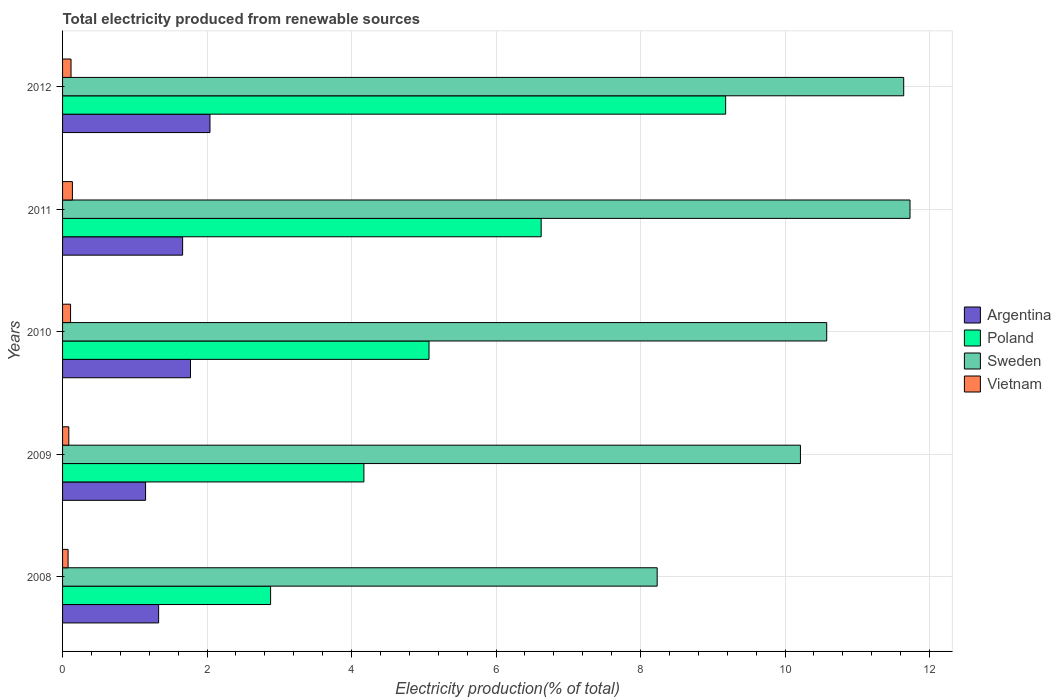Are the number of bars per tick equal to the number of legend labels?
Your answer should be very brief. Yes. How many bars are there on the 4th tick from the top?
Your answer should be very brief. 4. How many bars are there on the 3rd tick from the bottom?
Your answer should be very brief. 4. In how many cases, is the number of bars for a given year not equal to the number of legend labels?
Provide a short and direct response. 0. What is the total electricity produced in Sweden in 2012?
Offer a very short reply. 11.64. Across all years, what is the maximum total electricity produced in Poland?
Your response must be concise. 9.18. Across all years, what is the minimum total electricity produced in Argentina?
Keep it short and to the point. 1.15. In which year was the total electricity produced in Vietnam maximum?
Make the answer very short. 2011. What is the total total electricity produced in Argentina in the graph?
Offer a terse response. 7.95. What is the difference between the total electricity produced in Poland in 2009 and that in 2012?
Your answer should be very brief. -5.01. What is the difference between the total electricity produced in Sweden in 2008 and the total electricity produced in Vietnam in 2012?
Give a very brief answer. 8.11. What is the average total electricity produced in Poland per year?
Your response must be concise. 5.59. In the year 2012, what is the difference between the total electricity produced in Poland and total electricity produced in Vietnam?
Offer a terse response. 9.06. What is the ratio of the total electricity produced in Poland in 2009 to that in 2010?
Make the answer very short. 0.82. What is the difference between the highest and the second highest total electricity produced in Poland?
Offer a terse response. 2.55. What is the difference between the highest and the lowest total electricity produced in Vietnam?
Keep it short and to the point. 0.06. Is it the case that in every year, the sum of the total electricity produced in Vietnam and total electricity produced in Sweden is greater than the sum of total electricity produced in Argentina and total electricity produced in Poland?
Provide a short and direct response. Yes. Is it the case that in every year, the sum of the total electricity produced in Poland and total electricity produced in Sweden is greater than the total electricity produced in Argentina?
Make the answer very short. Yes. How many bars are there?
Provide a short and direct response. 20. How many years are there in the graph?
Your answer should be very brief. 5. Are the values on the major ticks of X-axis written in scientific E-notation?
Your response must be concise. No. Does the graph contain any zero values?
Your answer should be very brief. No. Does the graph contain grids?
Offer a terse response. Yes. How are the legend labels stacked?
Give a very brief answer. Vertical. What is the title of the graph?
Provide a short and direct response. Total electricity produced from renewable sources. Does "Japan" appear as one of the legend labels in the graph?
Offer a terse response. No. What is the label or title of the X-axis?
Your answer should be very brief. Electricity production(% of total). What is the label or title of the Y-axis?
Provide a succinct answer. Years. What is the Electricity production(% of total) in Argentina in 2008?
Give a very brief answer. 1.33. What is the Electricity production(% of total) in Poland in 2008?
Give a very brief answer. 2.88. What is the Electricity production(% of total) in Sweden in 2008?
Your answer should be very brief. 8.23. What is the Electricity production(% of total) in Vietnam in 2008?
Keep it short and to the point. 0.08. What is the Electricity production(% of total) in Argentina in 2009?
Make the answer very short. 1.15. What is the Electricity production(% of total) of Poland in 2009?
Provide a succinct answer. 4.17. What is the Electricity production(% of total) in Sweden in 2009?
Your answer should be compact. 10.21. What is the Electricity production(% of total) of Vietnam in 2009?
Make the answer very short. 0.09. What is the Electricity production(% of total) of Argentina in 2010?
Provide a short and direct response. 1.77. What is the Electricity production(% of total) of Poland in 2010?
Provide a short and direct response. 5.07. What is the Electricity production(% of total) in Sweden in 2010?
Your answer should be compact. 10.58. What is the Electricity production(% of total) of Vietnam in 2010?
Offer a terse response. 0.11. What is the Electricity production(% of total) of Argentina in 2011?
Offer a terse response. 1.66. What is the Electricity production(% of total) in Poland in 2011?
Offer a terse response. 6.62. What is the Electricity production(% of total) of Sweden in 2011?
Your answer should be compact. 11.73. What is the Electricity production(% of total) in Vietnam in 2011?
Make the answer very short. 0.14. What is the Electricity production(% of total) in Argentina in 2012?
Make the answer very short. 2.04. What is the Electricity production(% of total) of Poland in 2012?
Your answer should be compact. 9.18. What is the Electricity production(% of total) in Sweden in 2012?
Ensure brevity in your answer.  11.64. What is the Electricity production(% of total) of Vietnam in 2012?
Your answer should be very brief. 0.12. Across all years, what is the maximum Electricity production(% of total) of Argentina?
Ensure brevity in your answer.  2.04. Across all years, what is the maximum Electricity production(% of total) in Poland?
Keep it short and to the point. 9.18. Across all years, what is the maximum Electricity production(% of total) of Sweden?
Provide a succinct answer. 11.73. Across all years, what is the maximum Electricity production(% of total) in Vietnam?
Your answer should be very brief. 0.14. Across all years, what is the minimum Electricity production(% of total) in Argentina?
Make the answer very short. 1.15. Across all years, what is the minimum Electricity production(% of total) in Poland?
Give a very brief answer. 2.88. Across all years, what is the minimum Electricity production(% of total) in Sweden?
Provide a short and direct response. 8.23. Across all years, what is the minimum Electricity production(% of total) in Vietnam?
Provide a succinct answer. 0.08. What is the total Electricity production(% of total) in Argentina in the graph?
Provide a succinct answer. 7.95. What is the total Electricity production(% of total) of Poland in the graph?
Offer a terse response. 27.93. What is the total Electricity production(% of total) in Sweden in the graph?
Offer a very short reply. 52.39. What is the total Electricity production(% of total) of Vietnam in the graph?
Your response must be concise. 0.53. What is the difference between the Electricity production(% of total) in Argentina in 2008 and that in 2009?
Offer a very short reply. 0.18. What is the difference between the Electricity production(% of total) of Poland in 2008 and that in 2009?
Provide a short and direct response. -1.29. What is the difference between the Electricity production(% of total) in Sweden in 2008 and that in 2009?
Your answer should be very brief. -1.98. What is the difference between the Electricity production(% of total) of Vietnam in 2008 and that in 2009?
Offer a very short reply. -0.01. What is the difference between the Electricity production(% of total) of Argentina in 2008 and that in 2010?
Keep it short and to the point. -0.44. What is the difference between the Electricity production(% of total) in Poland in 2008 and that in 2010?
Ensure brevity in your answer.  -2.19. What is the difference between the Electricity production(% of total) in Sweden in 2008 and that in 2010?
Keep it short and to the point. -2.35. What is the difference between the Electricity production(% of total) in Vietnam in 2008 and that in 2010?
Provide a short and direct response. -0.03. What is the difference between the Electricity production(% of total) of Argentina in 2008 and that in 2011?
Your answer should be very brief. -0.33. What is the difference between the Electricity production(% of total) of Poland in 2008 and that in 2011?
Your answer should be very brief. -3.75. What is the difference between the Electricity production(% of total) in Sweden in 2008 and that in 2011?
Offer a very short reply. -3.5. What is the difference between the Electricity production(% of total) in Vietnam in 2008 and that in 2011?
Provide a short and direct response. -0.06. What is the difference between the Electricity production(% of total) of Argentina in 2008 and that in 2012?
Keep it short and to the point. -0.71. What is the difference between the Electricity production(% of total) of Poland in 2008 and that in 2012?
Your response must be concise. -6.3. What is the difference between the Electricity production(% of total) in Sweden in 2008 and that in 2012?
Offer a terse response. -3.41. What is the difference between the Electricity production(% of total) in Vietnam in 2008 and that in 2012?
Provide a succinct answer. -0.04. What is the difference between the Electricity production(% of total) of Argentina in 2009 and that in 2010?
Make the answer very short. -0.62. What is the difference between the Electricity production(% of total) of Poland in 2009 and that in 2010?
Provide a succinct answer. -0.9. What is the difference between the Electricity production(% of total) of Sweden in 2009 and that in 2010?
Offer a very short reply. -0.36. What is the difference between the Electricity production(% of total) in Vietnam in 2009 and that in 2010?
Provide a succinct answer. -0.02. What is the difference between the Electricity production(% of total) of Argentina in 2009 and that in 2011?
Make the answer very short. -0.51. What is the difference between the Electricity production(% of total) in Poland in 2009 and that in 2011?
Provide a short and direct response. -2.45. What is the difference between the Electricity production(% of total) in Sweden in 2009 and that in 2011?
Give a very brief answer. -1.52. What is the difference between the Electricity production(% of total) in Vietnam in 2009 and that in 2011?
Ensure brevity in your answer.  -0.05. What is the difference between the Electricity production(% of total) in Argentina in 2009 and that in 2012?
Ensure brevity in your answer.  -0.89. What is the difference between the Electricity production(% of total) of Poland in 2009 and that in 2012?
Give a very brief answer. -5.01. What is the difference between the Electricity production(% of total) in Sweden in 2009 and that in 2012?
Offer a terse response. -1.43. What is the difference between the Electricity production(% of total) in Vietnam in 2009 and that in 2012?
Offer a very short reply. -0.03. What is the difference between the Electricity production(% of total) in Argentina in 2010 and that in 2011?
Provide a succinct answer. 0.11. What is the difference between the Electricity production(% of total) in Poland in 2010 and that in 2011?
Your answer should be compact. -1.55. What is the difference between the Electricity production(% of total) in Sweden in 2010 and that in 2011?
Your answer should be very brief. -1.15. What is the difference between the Electricity production(% of total) in Vietnam in 2010 and that in 2011?
Keep it short and to the point. -0.03. What is the difference between the Electricity production(% of total) in Argentina in 2010 and that in 2012?
Your answer should be compact. -0.27. What is the difference between the Electricity production(% of total) in Poland in 2010 and that in 2012?
Give a very brief answer. -4.11. What is the difference between the Electricity production(% of total) in Sweden in 2010 and that in 2012?
Keep it short and to the point. -1.07. What is the difference between the Electricity production(% of total) of Vietnam in 2010 and that in 2012?
Your answer should be very brief. -0.01. What is the difference between the Electricity production(% of total) in Argentina in 2011 and that in 2012?
Make the answer very short. -0.38. What is the difference between the Electricity production(% of total) in Poland in 2011 and that in 2012?
Offer a terse response. -2.55. What is the difference between the Electricity production(% of total) of Sweden in 2011 and that in 2012?
Give a very brief answer. 0.09. What is the difference between the Electricity production(% of total) in Vietnam in 2011 and that in 2012?
Keep it short and to the point. 0.02. What is the difference between the Electricity production(% of total) in Argentina in 2008 and the Electricity production(% of total) in Poland in 2009?
Offer a terse response. -2.84. What is the difference between the Electricity production(% of total) of Argentina in 2008 and the Electricity production(% of total) of Sweden in 2009?
Offer a terse response. -8.88. What is the difference between the Electricity production(% of total) in Argentina in 2008 and the Electricity production(% of total) in Vietnam in 2009?
Your response must be concise. 1.24. What is the difference between the Electricity production(% of total) in Poland in 2008 and the Electricity production(% of total) in Sweden in 2009?
Your answer should be compact. -7.33. What is the difference between the Electricity production(% of total) of Poland in 2008 and the Electricity production(% of total) of Vietnam in 2009?
Provide a succinct answer. 2.79. What is the difference between the Electricity production(% of total) of Sweden in 2008 and the Electricity production(% of total) of Vietnam in 2009?
Make the answer very short. 8.14. What is the difference between the Electricity production(% of total) of Argentina in 2008 and the Electricity production(% of total) of Poland in 2010?
Offer a terse response. -3.74. What is the difference between the Electricity production(% of total) in Argentina in 2008 and the Electricity production(% of total) in Sweden in 2010?
Your response must be concise. -9.25. What is the difference between the Electricity production(% of total) of Argentina in 2008 and the Electricity production(% of total) of Vietnam in 2010?
Keep it short and to the point. 1.22. What is the difference between the Electricity production(% of total) in Poland in 2008 and the Electricity production(% of total) in Sweden in 2010?
Provide a short and direct response. -7.7. What is the difference between the Electricity production(% of total) of Poland in 2008 and the Electricity production(% of total) of Vietnam in 2010?
Offer a very short reply. 2.77. What is the difference between the Electricity production(% of total) in Sweden in 2008 and the Electricity production(% of total) in Vietnam in 2010?
Make the answer very short. 8.12. What is the difference between the Electricity production(% of total) in Argentina in 2008 and the Electricity production(% of total) in Poland in 2011?
Give a very brief answer. -5.29. What is the difference between the Electricity production(% of total) in Argentina in 2008 and the Electricity production(% of total) in Sweden in 2011?
Your answer should be compact. -10.4. What is the difference between the Electricity production(% of total) of Argentina in 2008 and the Electricity production(% of total) of Vietnam in 2011?
Offer a terse response. 1.19. What is the difference between the Electricity production(% of total) in Poland in 2008 and the Electricity production(% of total) in Sweden in 2011?
Your response must be concise. -8.85. What is the difference between the Electricity production(% of total) of Poland in 2008 and the Electricity production(% of total) of Vietnam in 2011?
Your answer should be very brief. 2.74. What is the difference between the Electricity production(% of total) in Sweden in 2008 and the Electricity production(% of total) in Vietnam in 2011?
Make the answer very short. 8.09. What is the difference between the Electricity production(% of total) of Argentina in 2008 and the Electricity production(% of total) of Poland in 2012?
Give a very brief answer. -7.85. What is the difference between the Electricity production(% of total) in Argentina in 2008 and the Electricity production(% of total) in Sweden in 2012?
Your answer should be very brief. -10.31. What is the difference between the Electricity production(% of total) in Argentina in 2008 and the Electricity production(% of total) in Vietnam in 2012?
Offer a very short reply. 1.21. What is the difference between the Electricity production(% of total) in Poland in 2008 and the Electricity production(% of total) in Sweden in 2012?
Your answer should be very brief. -8.76. What is the difference between the Electricity production(% of total) of Poland in 2008 and the Electricity production(% of total) of Vietnam in 2012?
Provide a short and direct response. 2.76. What is the difference between the Electricity production(% of total) in Sweden in 2008 and the Electricity production(% of total) in Vietnam in 2012?
Ensure brevity in your answer.  8.11. What is the difference between the Electricity production(% of total) of Argentina in 2009 and the Electricity production(% of total) of Poland in 2010?
Your answer should be compact. -3.92. What is the difference between the Electricity production(% of total) of Argentina in 2009 and the Electricity production(% of total) of Sweden in 2010?
Give a very brief answer. -9.43. What is the difference between the Electricity production(% of total) of Argentina in 2009 and the Electricity production(% of total) of Vietnam in 2010?
Make the answer very short. 1.04. What is the difference between the Electricity production(% of total) of Poland in 2009 and the Electricity production(% of total) of Sweden in 2010?
Give a very brief answer. -6.41. What is the difference between the Electricity production(% of total) of Poland in 2009 and the Electricity production(% of total) of Vietnam in 2010?
Keep it short and to the point. 4.06. What is the difference between the Electricity production(% of total) in Sweden in 2009 and the Electricity production(% of total) in Vietnam in 2010?
Keep it short and to the point. 10.1. What is the difference between the Electricity production(% of total) in Argentina in 2009 and the Electricity production(% of total) in Poland in 2011?
Provide a short and direct response. -5.48. What is the difference between the Electricity production(% of total) in Argentina in 2009 and the Electricity production(% of total) in Sweden in 2011?
Provide a succinct answer. -10.58. What is the difference between the Electricity production(% of total) of Poland in 2009 and the Electricity production(% of total) of Sweden in 2011?
Provide a short and direct response. -7.56. What is the difference between the Electricity production(% of total) in Poland in 2009 and the Electricity production(% of total) in Vietnam in 2011?
Give a very brief answer. 4.03. What is the difference between the Electricity production(% of total) of Sweden in 2009 and the Electricity production(% of total) of Vietnam in 2011?
Provide a short and direct response. 10.08. What is the difference between the Electricity production(% of total) of Argentina in 2009 and the Electricity production(% of total) of Poland in 2012?
Your answer should be very brief. -8.03. What is the difference between the Electricity production(% of total) of Argentina in 2009 and the Electricity production(% of total) of Sweden in 2012?
Offer a very short reply. -10.49. What is the difference between the Electricity production(% of total) in Argentina in 2009 and the Electricity production(% of total) in Vietnam in 2012?
Offer a terse response. 1.03. What is the difference between the Electricity production(% of total) of Poland in 2009 and the Electricity production(% of total) of Sweden in 2012?
Ensure brevity in your answer.  -7.47. What is the difference between the Electricity production(% of total) in Poland in 2009 and the Electricity production(% of total) in Vietnam in 2012?
Make the answer very short. 4.05. What is the difference between the Electricity production(% of total) in Sweden in 2009 and the Electricity production(% of total) in Vietnam in 2012?
Offer a very short reply. 10.1. What is the difference between the Electricity production(% of total) of Argentina in 2010 and the Electricity production(% of total) of Poland in 2011?
Keep it short and to the point. -4.85. What is the difference between the Electricity production(% of total) of Argentina in 2010 and the Electricity production(% of total) of Sweden in 2011?
Offer a terse response. -9.96. What is the difference between the Electricity production(% of total) in Argentina in 2010 and the Electricity production(% of total) in Vietnam in 2011?
Provide a succinct answer. 1.63. What is the difference between the Electricity production(% of total) of Poland in 2010 and the Electricity production(% of total) of Sweden in 2011?
Offer a terse response. -6.66. What is the difference between the Electricity production(% of total) of Poland in 2010 and the Electricity production(% of total) of Vietnam in 2011?
Keep it short and to the point. 4.94. What is the difference between the Electricity production(% of total) of Sweden in 2010 and the Electricity production(% of total) of Vietnam in 2011?
Your answer should be compact. 10.44. What is the difference between the Electricity production(% of total) of Argentina in 2010 and the Electricity production(% of total) of Poland in 2012?
Offer a terse response. -7.41. What is the difference between the Electricity production(% of total) of Argentina in 2010 and the Electricity production(% of total) of Sweden in 2012?
Keep it short and to the point. -9.87. What is the difference between the Electricity production(% of total) in Argentina in 2010 and the Electricity production(% of total) in Vietnam in 2012?
Keep it short and to the point. 1.65. What is the difference between the Electricity production(% of total) of Poland in 2010 and the Electricity production(% of total) of Sweden in 2012?
Offer a very short reply. -6.57. What is the difference between the Electricity production(% of total) in Poland in 2010 and the Electricity production(% of total) in Vietnam in 2012?
Make the answer very short. 4.96. What is the difference between the Electricity production(% of total) in Sweden in 2010 and the Electricity production(% of total) in Vietnam in 2012?
Ensure brevity in your answer.  10.46. What is the difference between the Electricity production(% of total) of Argentina in 2011 and the Electricity production(% of total) of Poland in 2012?
Offer a terse response. -7.52. What is the difference between the Electricity production(% of total) in Argentina in 2011 and the Electricity production(% of total) in Sweden in 2012?
Your answer should be compact. -9.98. What is the difference between the Electricity production(% of total) of Argentina in 2011 and the Electricity production(% of total) of Vietnam in 2012?
Offer a very short reply. 1.54. What is the difference between the Electricity production(% of total) in Poland in 2011 and the Electricity production(% of total) in Sweden in 2012?
Offer a very short reply. -5.02. What is the difference between the Electricity production(% of total) in Poland in 2011 and the Electricity production(% of total) in Vietnam in 2012?
Give a very brief answer. 6.51. What is the difference between the Electricity production(% of total) of Sweden in 2011 and the Electricity production(% of total) of Vietnam in 2012?
Provide a succinct answer. 11.61. What is the average Electricity production(% of total) of Argentina per year?
Your response must be concise. 1.59. What is the average Electricity production(% of total) in Poland per year?
Give a very brief answer. 5.59. What is the average Electricity production(% of total) in Sweden per year?
Offer a very short reply. 10.48. What is the average Electricity production(% of total) of Vietnam per year?
Give a very brief answer. 0.11. In the year 2008, what is the difference between the Electricity production(% of total) in Argentina and Electricity production(% of total) in Poland?
Your answer should be compact. -1.55. In the year 2008, what is the difference between the Electricity production(% of total) of Argentina and Electricity production(% of total) of Sweden?
Ensure brevity in your answer.  -6.9. In the year 2008, what is the difference between the Electricity production(% of total) of Argentina and Electricity production(% of total) of Vietnam?
Give a very brief answer. 1.25. In the year 2008, what is the difference between the Electricity production(% of total) of Poland and Electricity production(% of total) of Sweden?
Give a very brief answer. -5.35. In the year 2008, what is the difference between the Electricity production(% of total) of Poland and Electricity production(% of total) of Vietnam?
Your answer should be very brief. 2.8. In the year 2008, what is the difference between the Electricity production(% of total) in Sweden and Electricity production(% of total) in Vietnam?
Provide a short and direct response. 8.15. In the year 2009, what is the difference between the Electricity production(% of total) of Argentina and Electricity production(% of total) of Poland?
Ensure brevity in your answer.  -3.02. In the year 2009, what is the difference between the Electricity production(% of total) in Argentina and Electricity production(% of total) in Sweden?
Keep it short and to the point. -9.06. In the year 2009, what is the difference between the Electricity production(% of total) of Argentina and Electricity production(% of total) of Vietnam?
Offer a terse response. 1.06. In the year 2009, what is the difference between the Electricity production(% of total) of Poland and Electricity production(% of total) of Sweden?
Make the answer very short. -6.04. In the year 2009, what is the difference between the Electricity production(% of total) in Poland and Electricity production(% of total) in Vietnam?
Provide a succinct answer. 4.08. In the year 2009, what is the difference between the Electricity production(% of total) in Sweden and Electricity production(% of total) in Vietnam?
Provide a short and direct response. 10.13. In the year 2010, what is the difference between the Electricity production(% of total) in Argentina and Electricity production(% of total) in Poland?
Provide a short and direct response. -3.3. In the year 2010, what is the difference between the Electricity production(% of total) of Argentina and Electricity production(% of total) of Sweden?
Give a very brief answer. -8.81. In the year 2010, what is the difference between the Electricity production(% of total) in Argentina and Electricity production(% of total) in Vietnam?
Your answer should be very brief. 1.66. In the year 2010, what is the difference between the Electricity production(% of total) in Poland and Electricity production(% of total) in Sweden?
Offer a terse response. -5.5. In the year 2010, what is the difference between the Electricity production(% of total) of Poland and Electricity production(% of total) of Vietnam?
Provide a succinct answer. 4.96. In the year 2010, what is the difference between the Electricity production(% of total) in Sweden and Electricity production(% of total) in Vietnam?
Offer a terse response. 10.47. In the year 2011, what is the difference between the Electricity production(% of total) in Argentina and Electricity production(% of total) in Poland?
Keep it short and to the point. -4.96. In the year 2011, what is the difference between the Electricity production(% of total) in Argentina and Electricity production(% of total) in Sweden?
Make the answer very short. -10.07. In the year 2011, what is the difference between the Electricity production(% of total) of Argentina and Electricity production(% of total) of Vietnam?
Offer a very short reply. 1.53. In the year 2011, what is the difference between the Electricity production(% of total) in Poland and Electricity production(% of total) in Sweden?
Offer a terse response. -5.11. In the year 2011, what is the difference between the Electricity production(% of total) in Poland and Electricity production(% of total) in Vietnam?
Make the answer very short. 6.49. In the year 2011, what is the difference between the Electricity production(% of total) of Sweden and Electricity production(% of total) of Vietnam?
Give a very brief answer. 11.59. In the year 2012, what is the difference between the Electricity production(% of total) in Argentina and Electricity production(% of total) in Poland?
Keep it short and to the point. -7.14. In the year 2012, what is the difference between the Electricity production(% of total) in Argentina and Electricity production(% of total) in Sweden?
Make the answer very short. -9.6. In the year 2012, what is the difference between the Electricity production(% of total) in Argentina and Electricity production(% of total) in Vietnam?
Give a very brief answer. 1.92. In the year 2012, what is the difference between the Electricity production(% of total) in Poland and Electricity production(% of total) in Sweden?
Provide a succinct answer. -2.46. In the year 2012, what is the difference between the Electricity production(% of total) of Poland and Electricity production(% of total) of Vietnam?
Provide a succinct answer. 9.06. In the year 2012, what is the difference between the Electricity production(% of total) in Sweden and Electricity production(% of total) in Vietnam?
Your response must be concise. 11.53. What is the ratio of the Electricity production(% of total) of Argentina in 2008 to that in 2009?
Your answer should be very brief. 1.16. What is the ratio of the Electricity production(% of total) in Poland in 2008 to that in 2009?
Provide a short and direct response. 0.69. What is the ratio of the Electricity production(% of total) of Sweden in 2008 to that in 2009?
Provide a short and direct response. 0.81. What is the ratio of the Electricity production(% of total) of Vietnam in 2008 to that in 2009?
Provide a short and direct response. 0.88. What is the ratio of the Electricity production(% of total) in Argentina in 2008 to that in 2010?
Ensure brevity in your answer.  0.75. What is the ratio of the Electricity production(% of total) in Poland in 2008 to that in 2010?
Give a very brief answer. 0.57. What is the ratio of the Electricity production(% of total) of Sweden in 2008 to that in 2010?
Offer a very short reply. 0.78. What is the ratio of the Electricity production(% of total) of Vietnam in 2008 to that in 2010?
Your response must be concise. 0.69. What is the ratio of the Electricity production(% of total) of Argentina in 2008 to that in 2011?
Provide a succinct answer. 0.8. What is the ratio of the Electricity production(% of total) in Poland in 2008 to that in 2011?
Give a very brief answer. 0.43. What is the ratio of the Electricity production(% of total) of Sweden in 2008 to that in 2011?
Offer a terse response. 0.7. What is the ratio of the Electricity production(% of total) in Vietnam in 2008 to that in 2011?
Your response must be concise. 0.56. What is the ratio of the Electricity production(% of total) in Argentina in 2008 to that in 2012?
Offer a very short reply. 0.65. What is the ratio of the Electricity production(% of total) in Poland in 2008 to that in 2012?
Ensure brevity in your answer.  0.31. What is the ratio of the Electricity production(% of total) of Sweden in 2008 to that in 2012?
Offer a very short reply. 0.71. What is the ratio of the Electricity production(% of total) of Vietnam in 2008 to that in 2012?
Your answer should be compact. 0.65. What is the ratio of the Electricity production(% of total) of Argentina in 2009 to that in 2010?
Provide a short and direct response. 0.65. What is the ratio of the Electricity production(% of total) in Poland in 2009 to that in 2010?
Your answer should be very brief. 0.82. What is the ratio of the Electricity production(% of total) of Sweden in 2009 to that in 2010?
Your response must be concise. 0.97. What is the ratio of the Electricity production(% of total) of Vietnam in 2009 to that in 2010?
Offer a terse response. 0.78. What is the ratio of the Electricity production(% of total) in Argentina in 2009 to that in 2011?
Your answer should be very brief. 0.69. What is the ratio of the Electricity production(% of total) of Poland in 2009 to that in 2011?
Provide a short and direct response. 0.63. What is the ratio of the Electricity production(% of total) of Sweden in 2009 to that in 2011?
Give a very brief answer. 0.87. What is the ratio of the Electricity production(% of total) in Vietnam in 2009 to that in 2011?
Your answer should be compact. 0.64. What is the ratio of the Electricity production(% of total) in Argentina in 2009 to that in 2012?
Provide a short and direct response. 0.56. What is the ratio of the Electricity production(% of total) in Poland in 2009 to that in 2012?
Your answer should be very brief. 0.45. What is the ratio of the Electricity production(% of total) in Sweden in 2009 to that in 2012?
Keep it short and to the point. 0.88. What is the ratio of the Electricity production(% of total) in Vietnam in 2009 to that in 2012?
Offer a terse response. 0.74. What is the ratio of the Electricity production(% of total) in Argentina in 2010 to that in 2011?
Offer a terse response. 1.07. What is the ratio of the Electricity production(% of total) of Poland in 2010 to that in 2011?
Provide a succinct answer. 0.77. What is the ratio of the Electricity production(% of total) of Sweden in 2010 to that in 2011?
Give a very brief answer. 0.9. What is the ratio of the Electricity production(% of total) of Vietnam in 2010 to that in 2011?
Ensure brevity in your answer.  0.81. What is the ratio of the Electricity production(% of total) of Argentina in 2010 to that in 2012?
Offer a terse response. 0.87. What is the ratio of the Electricity production(% of total) of Poland in 2010 to that in 2012?
Ensure brevity in your answer.  0.55. What is the ratio of the Electricity production(% of total) in Sweden in 2010 to that in 2012?
Offer a very short reply. 0.91. What is the ratio of the Electricity production(% of total) of Vietnam in 2010 to that in 2012?
Provide a short and direct response. 0.94. What is the ratio of the Electricity production(% of total) in Argentina in 2011 to that in 2012?
Ensure brevity in your answer.  0.81. What is the ratio of the Electricity production(% of total) in Poland in 2011 to that in 2012?
Offer a terse response. 0.72. What is the ratio of the Electricity production(% of total) of Sweden in 2011 to that in 2012?
Provide a short and direct response. 1.01. What is the ratio of the Electricity production(% of total) in Vietnam in 2011 to that in 2012?
Give a very brief answer. 1.16. What is the difference between the highest and the second highest Electricity production(% of total) of Argentina?
Your response must be concise. 0.27. What is the difference between the highest and the second highest Electricity production(% of total) of Poland?
Your answer should be compact. 2.55. What is the difference between the highest and the second highest Electricity production(% of total) of Sweden?
Offer a very short reply. 0.09. What is the difference between the highest and the second highest Electricity production(% of total) in Vietnam?
Offer a terse response. 0.02. What is the difference between the highest and the lowest Electricity production(% of total) in Argentina?
Provide a succinct answer. 0.89. What is the difference between the highest and the lowest Electricity production(% of total) in Poland?
Make the answer very short. 6.3. What is the difference between the highest and the lowest Electricity production(% of total) in Sweden?
Give a very brief answer. 3.5. What is the difference between the highest and the lowest Electricity production(% of total) of Vietnam?
Offer a terse response. 0.06. 